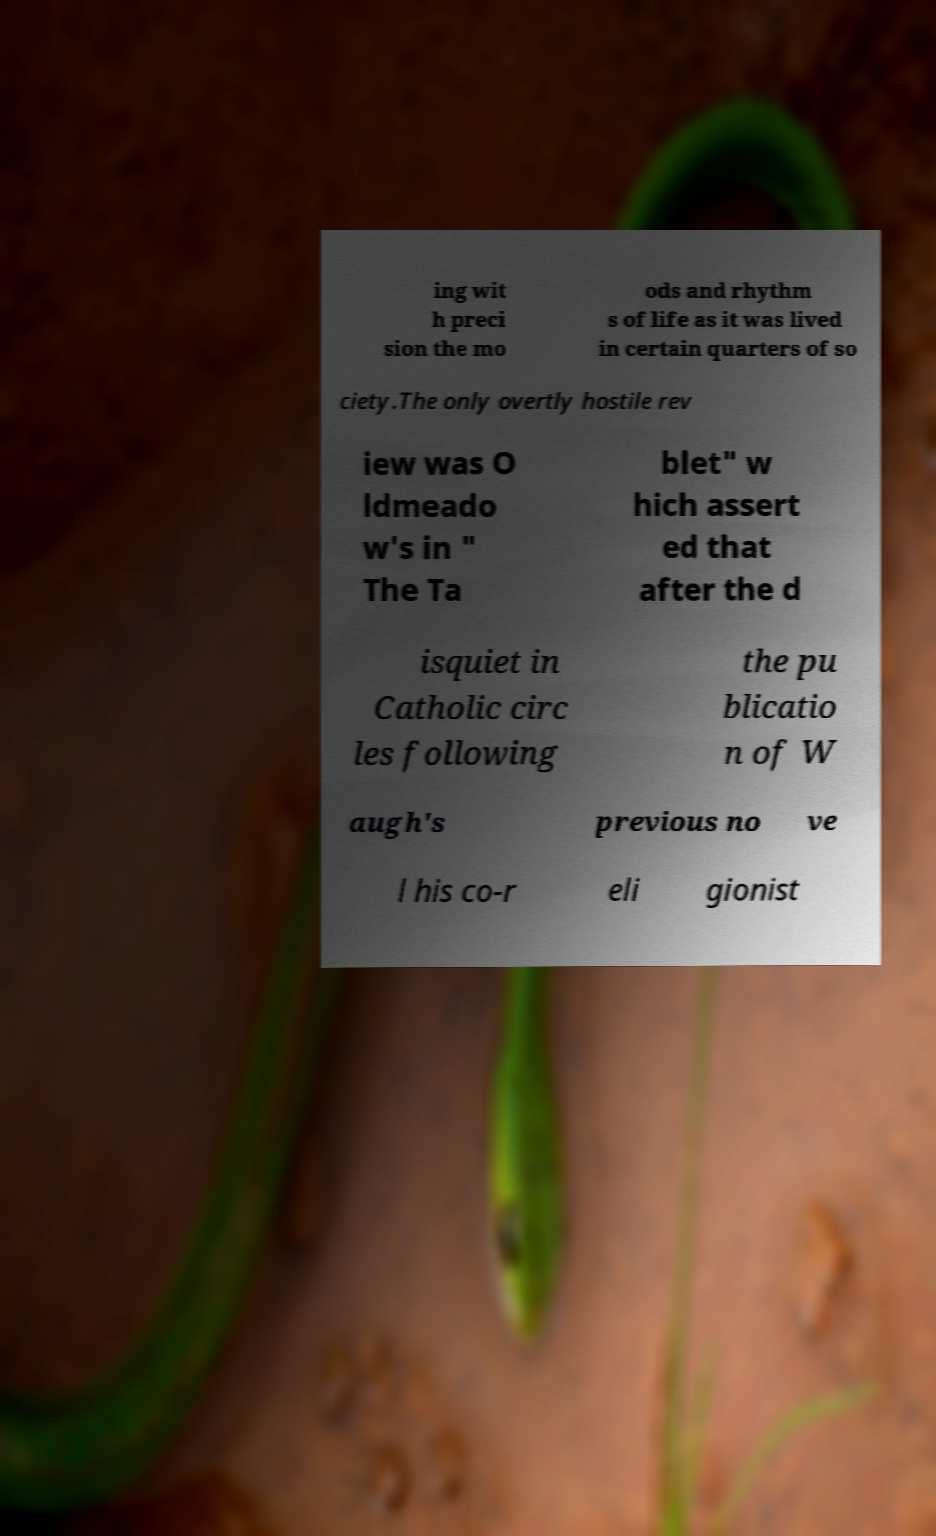Can you accurately transcribe the text from the provided image for me? ing wit h preci sion the mo ods and rhythm s of life as it was lived in certain quarters of so ciety.The only overtly hostile rev iew was O ldmeado w's in " The Ta blet" w hich assert ed that after the d isquiet in Catholic circ les following the pu blicatio n of W augh's previous no ve l his co-r eli gionist 